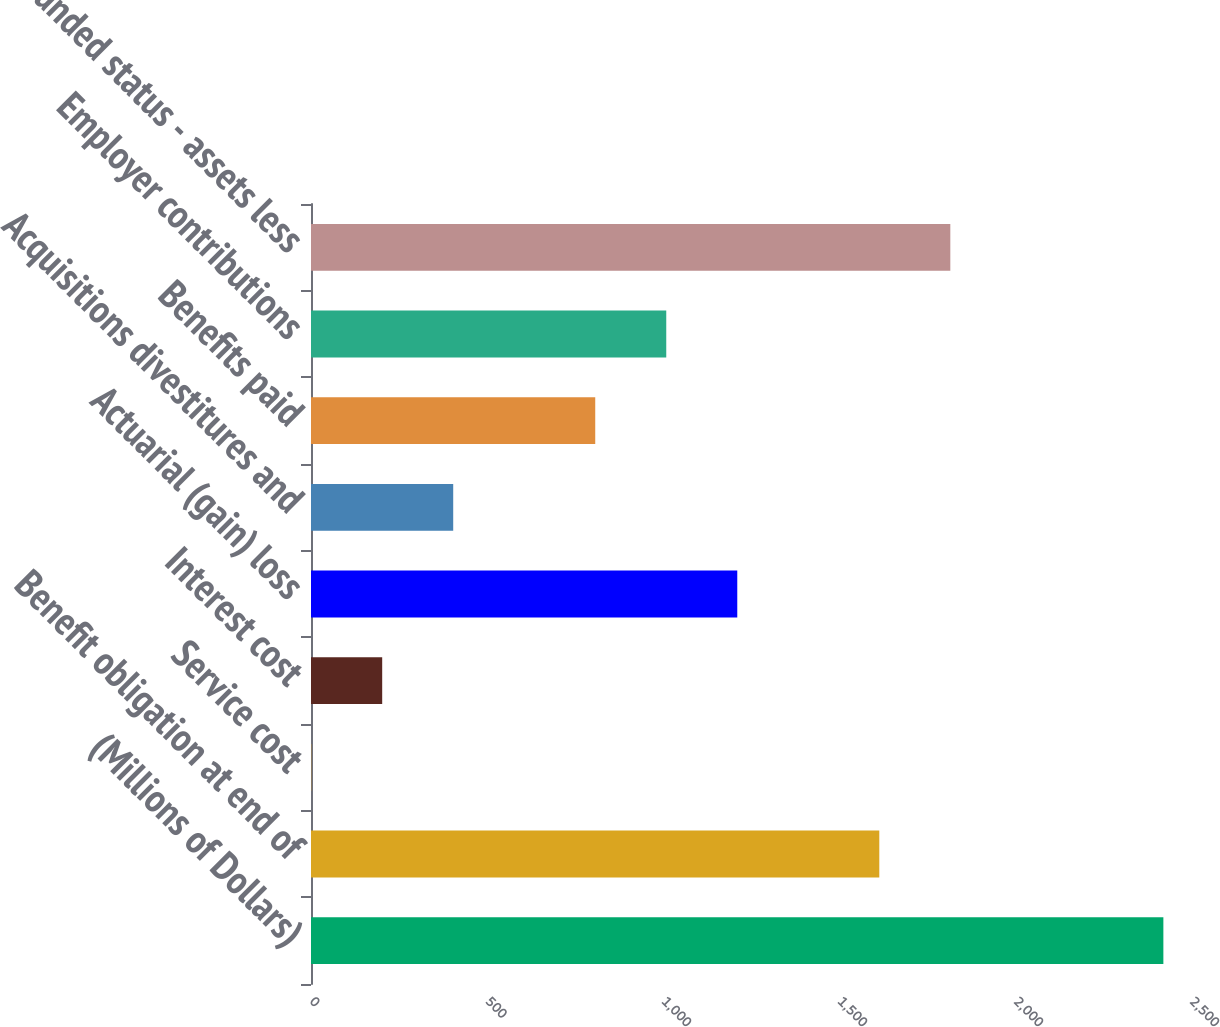<chart> <loc_0><loc_0><loc_500><loc_500><bar_chart><fcel>(Millions of Dollars)<fcel>Benefit obligation at end of<fcel>Service cost<fcel>Interest cost<fcel>Actuarial (gain) loss<fcel>Acquisitions divestitures and<fcel>Benefits paid<fcel>Employer contributions<fcel>Funded status - assets less<nl><fcel>2421.5<fcel>1614.5<fcel>0.5<fcel>202.25<fcel>1211<fcel>404<fcel>807.5<fcel>1009.25<fcel>1816.25<nl></chart> 